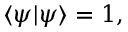Convert formula to latex. <formula><loc_0><loc_0><loc_500><loc_500>\langle \psi | \psi \rangle = 1 ,</formula> 